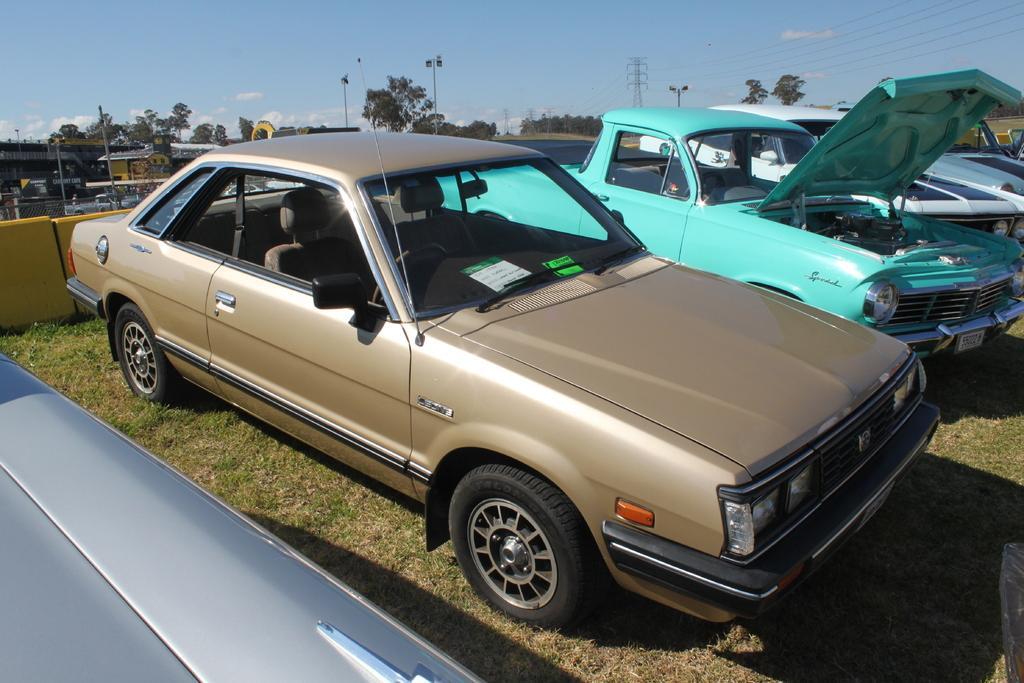Can you describe this image briefly? In the image there are few cars on the grassland, in the back there is a bridge on the left side and vehicles moving on the road with trees all over the place with current polls in the middle and above its sky with clouds. 